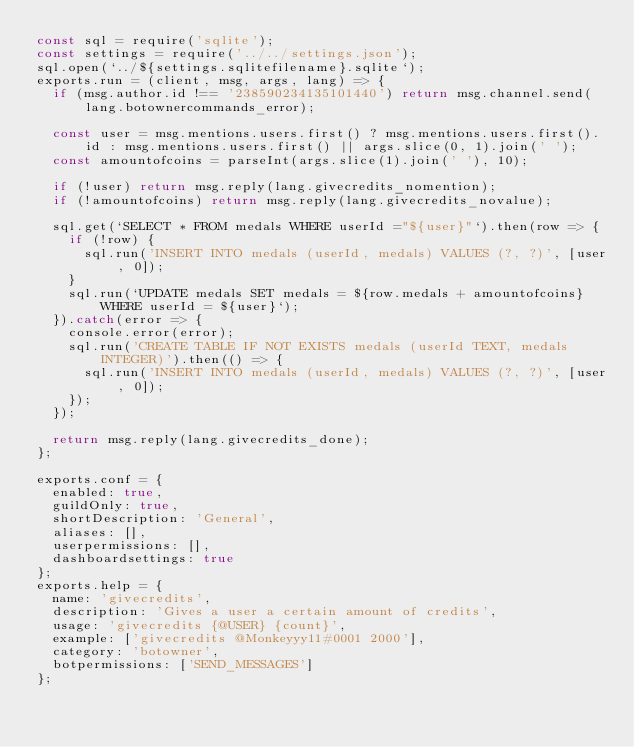<code> <loc_0><loc_0><loc_500><loc_500><_JavaScript_>const sql = require('sqlite');
const settings = require('../../settings.json');
sql.open(`../${settings.sqlitefilename}.sqlite`);
exports.run = (client, msg, args, lang) => {
	if (msg.author.id !== '238590234135101440') return msg.channel.send(lang.botownercommands_error);

	const user = msg.mentions.users.first() ? msg.mentions.users.first().id : msg.mentions.users.first() || args.slice(0, 1).join(' ');
	const amountofcoins = parseInt(args.slice(1).join(' '), 10);

	if (!user) return msg.reply(lang.givecredits_nomention);
	if (!amountofcoins) return msg.reply(lang.givecredits_novalue);

	sql.get(`SELECT * FROM medals WHERE userId ="${user}"`).then(row => {
		if (!row) {
			sql.run('INSERT INTO medals (userId, medals) VALUES (?, ?)', [user, 0]);
		}
		sql.run(`UPDATE medals SET medals = ${row.medals + amountofcoins} WHERE userId = ${user}`);
	}).catch(error => {
		console.error(error);
		sql.run('CREATE TABLE IF NOT EXISTS medals (userId TEXT, medals INTEGER)').then(() => {
			sql.run('INSERT INTO medals (userId, medals) VALUES (?, ?)', [user, 0]);
		});
	});

	return msg.reply(lang.givecredits_done);
};

exports.conf = {
	enabled: true,
	guildOnly: true,
	shortDescription: 'General',
	aliases: [],
	userpermissions: [],
	dashboardsettings: true
};
exports.help = {
	name: 'givecredits',
	description: 'Gives a user a certain amount of credits',
	usage: 'givecredits {@USER} {count}',
	example: ['givecredits @Monkeyyy11#0001 2000'],
	category: 'botowner',
	botpermissions: ['SEND_MESSAGES']
};
</code> 